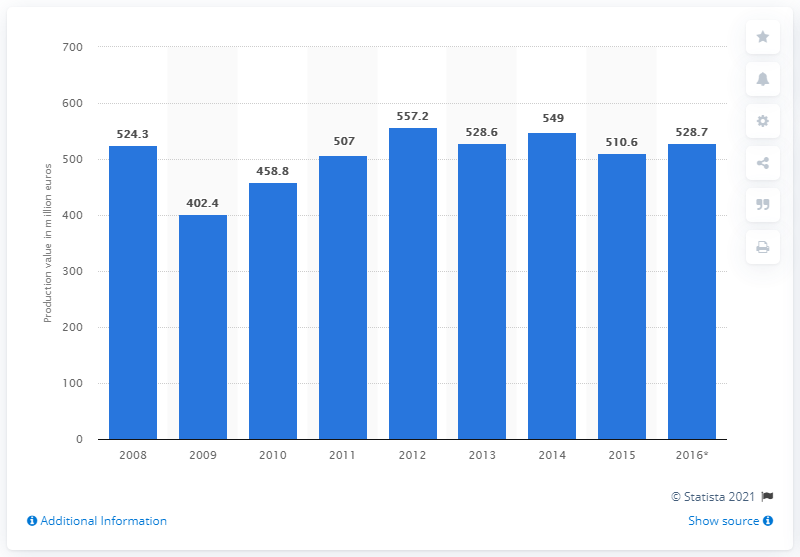Indicate a few pertinent items in this graphic. In 2015, the production value of the Norwegian textile manufacturing sector was 510.6 million U.S. dollars. 